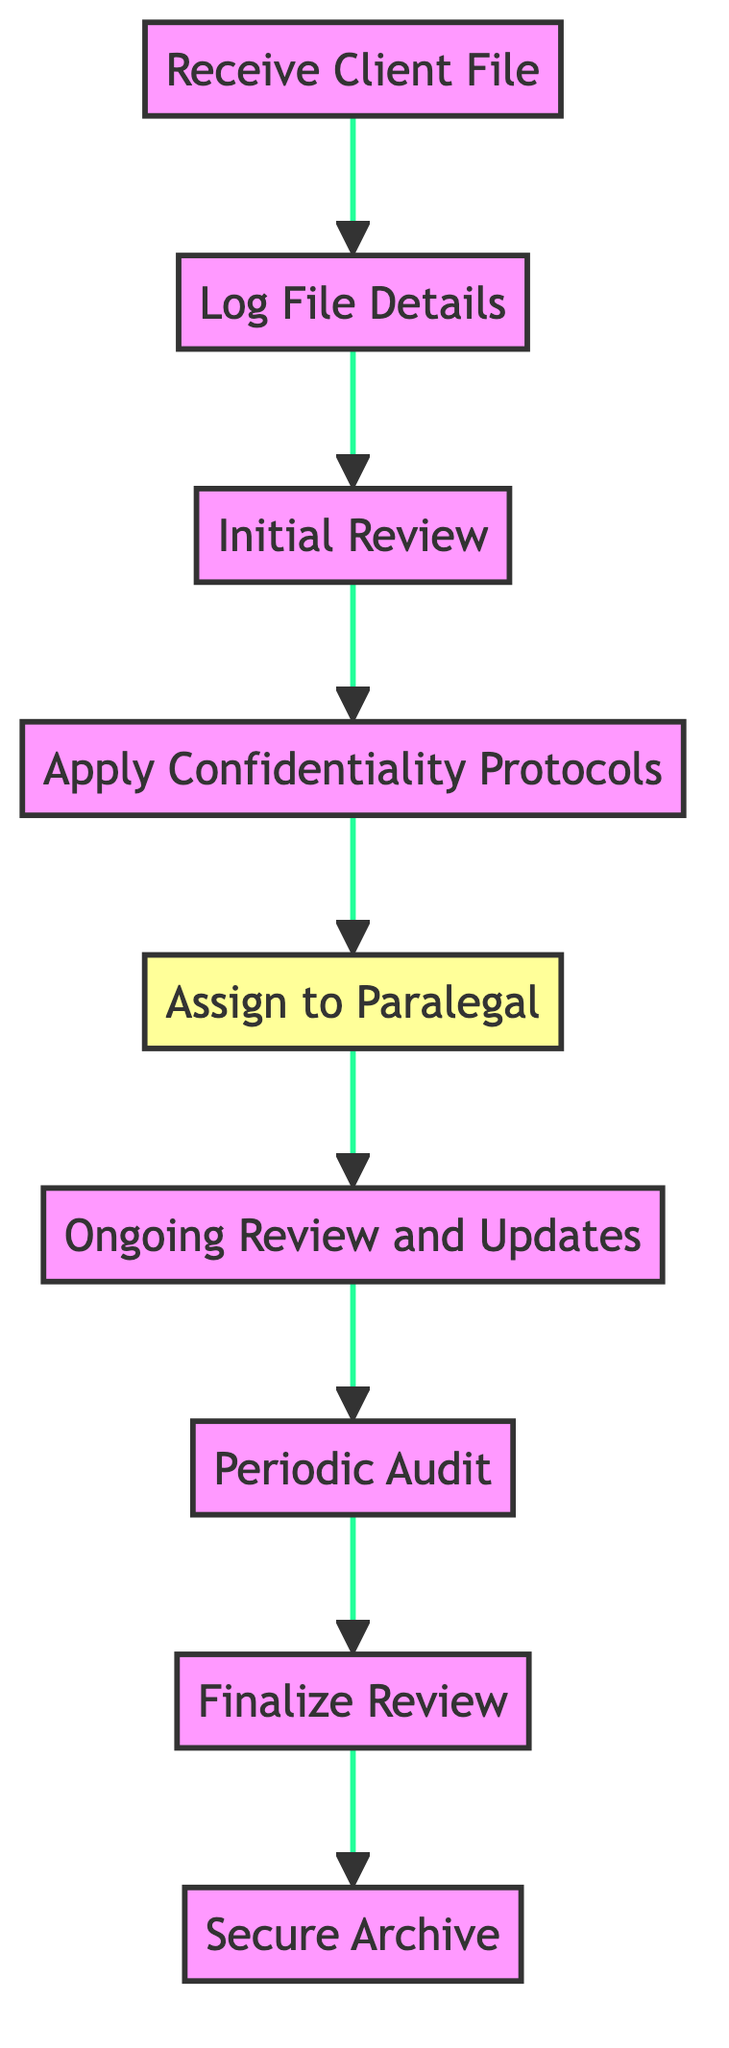What is the first element in the workflow? The first element in the workflow is "Receive Client File," which is the starting point of the diagram.
Answer: Receive Client File How many nodes are present in the diagram? The diagram consists of nine nodes that represent various steps in the workflow for reviewing and maintaining confidential client files.
Answer: 9 What follows after "Log File Details"? After "Log File Details," the next step is "Initial Review," indicating that the process continues with reviewing the information logged.
Answer: Initial Review Which step includes applying security measures? The step that involves applying security measures is "Apply Confidentiality Protocols," where confidentiality protocols are put in place.
Answer: Apply Confidentiality Protocols What is the conditional action associated with assigning the file? The conditional action indicates that if the file is sensitive, it should be assigned a higher security level, determined during the "Assign to Paralegal" step.
Answer: Higher security level Which node leads to the final step of the workflow? The node that leads to the final step, "Secure Archive," is "Finalize Review," indicating that the process must be completed before archiving the file.
Answer: Finalize Review What is done periodically according to the diagram? According to the diagram, "Periodic Audit" is the step performed periodically to ensure compliance with confidentiality standards.
Answer: Periodic Audit What document management system is mentioned in the workflow? The workflow mentions the "Case Management System (CMS)" as the system where client file details are logged.
Answer: Case Management System Which step ensures ongoing compliance with protocols? The step "Ongoing Review and Updates" ensures that all revisions and updates are compliant with confidentiality protocols throughout the file's management.
Answer: Ongoing Review and Updates 